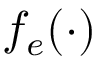<formula> <loc_0><loc_0><loc_500><loc_500>f _ { e } ( \cdot )</formula> 